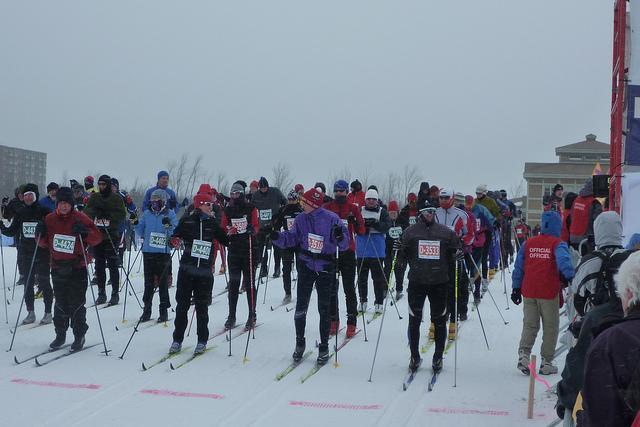How many women are wearing skirts?
Give a very brief answer. 0. How many ski can you see?
Give a very brief answer. 1. How many people are in the picture?
Give a very brief answer. 12. How many birds are flying?
Give a very brief answer. 0. 